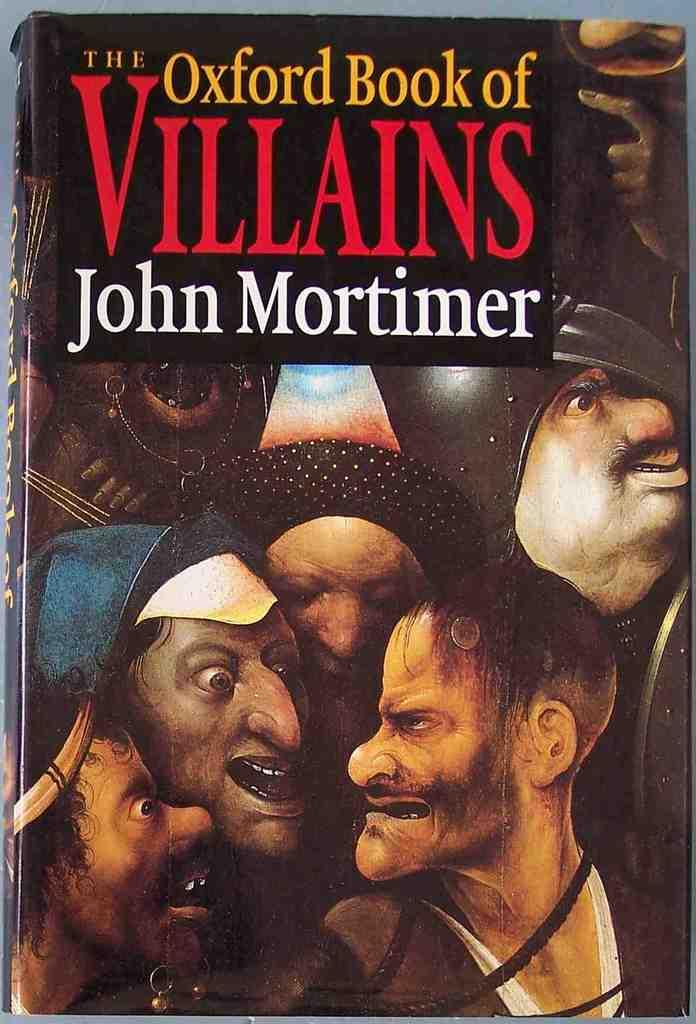What type of images can be seen on the front page of the book? The front page of the book contains cartoon images. What other type of content is present on the front page of the book? The front page of the book contains text. What type of tools does the carpenter use on the front page of the book? There is no carpenter or tools present on the front page of the book; it contains cartoon images and text. What type of legal advice is the lawyer providing on the front page of the book? There is no lawyer or legal advice present on the front page of the book; it contains cartoon images and text. 